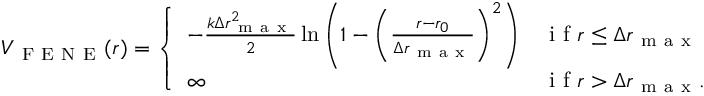<formula> <loc_0><loc_0><loc_500><loc_500>\begin{array} { r } { V _ { F E N E } ( r ) = \left \{ \begin{array} { l l } { - \frac { k \Delta r _ { m a x } ^ { 2 } } { 2 } \ln \left ( 1 - \left ( \frac { r - r _ { 0 } } { \Delta r _ { m a x } } \right ) ^ { 2 } \right ) } & { i f r \leq \Delta r _ { m a x } } \\ { \infty } & { i f r > \Delta r _ { m a x } . } \end{array} } \end{array}</formula> 